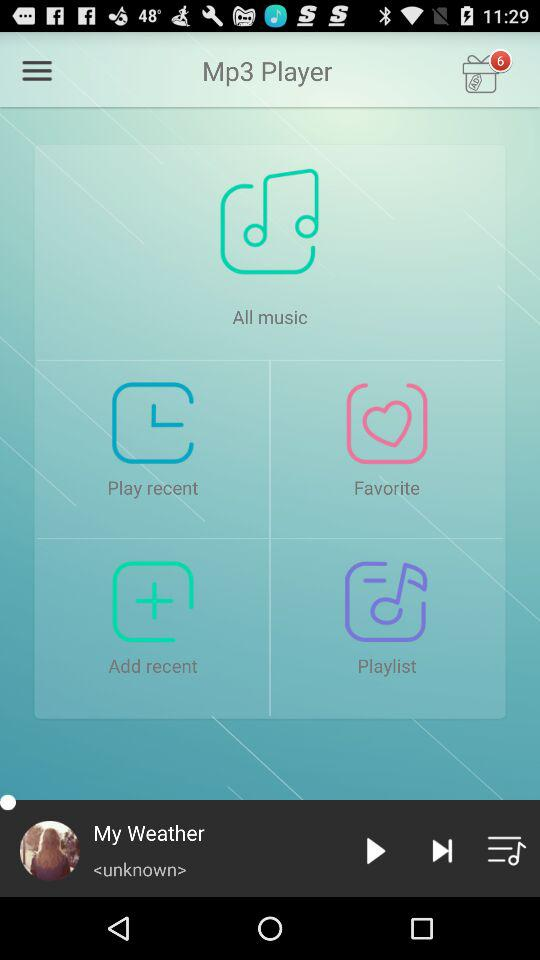What is the application name? The application name is "Mp3 Player". 